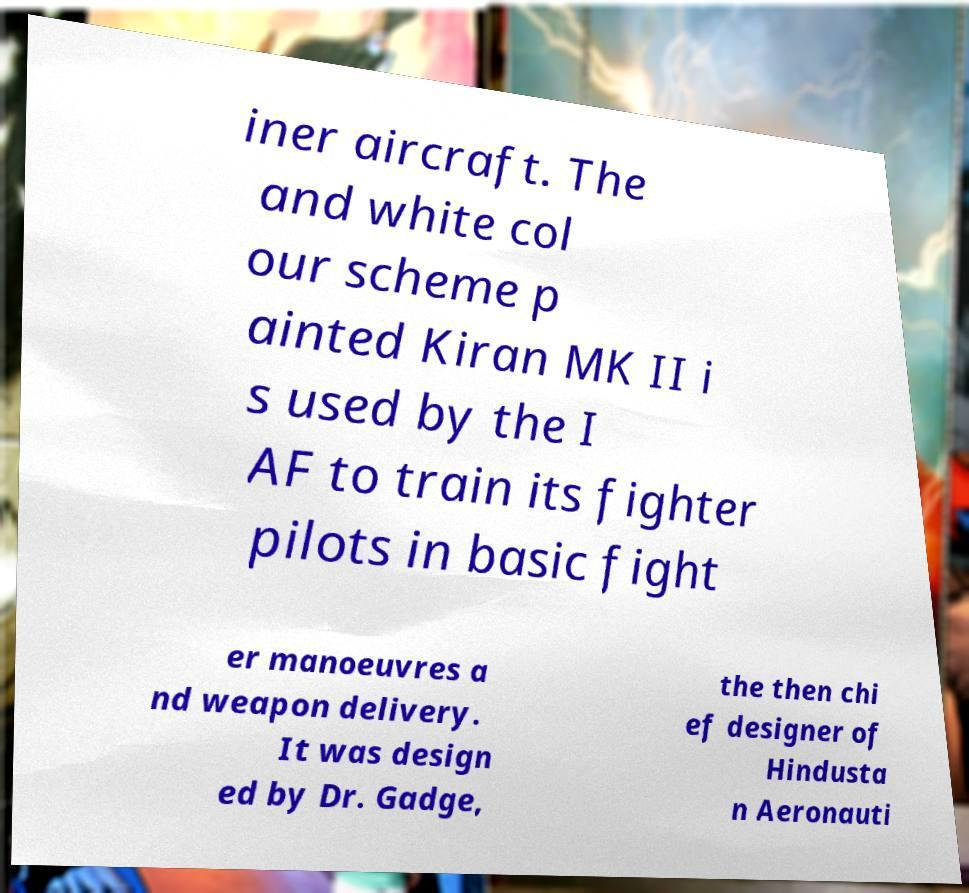Please read and relay the text visible in this image. What does it say? iner aircraft. The and white col our scheme p ainted Kiran MK II i s used by the I AF to train its fighter pilots in basic fight er manoeuvres a nd weapon delivery. It was design ed by Dr. Gadge, the then chi ef designer of Hindusta n Aeronauti 